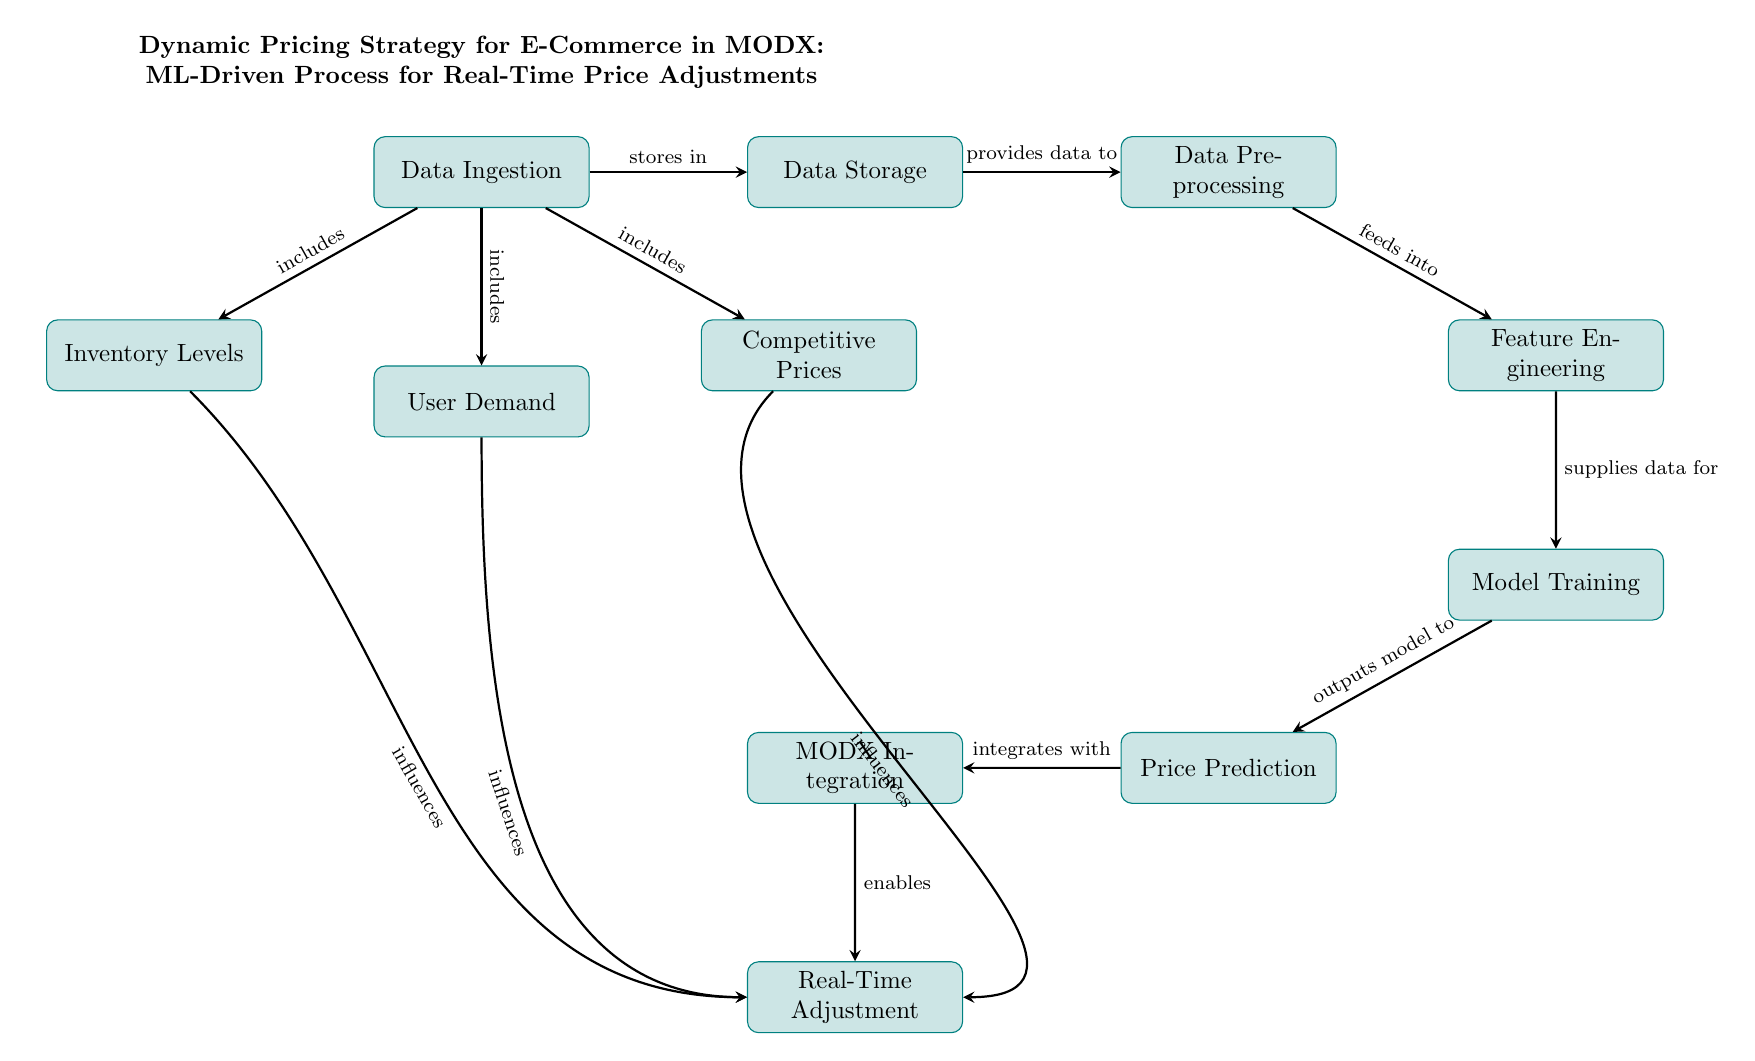What is the first step in the process? The first node in the diagram is "Data Ingestion," which represents the initial step of collecting various data types necessary for the dynamic pricing strategy.
Answer: Data Ingestion How many main processes are depicted in the diagram? The diagram includes a total of seven main processes, which are the nodes that represent steps in the machine learning-driven pricing strategy. These processes are connected by arrows indicating the flow of data.
Answer: Seven What influences the “Real-Time Adjustment”? The “Real-Time Adjustment” node is influenced by three specific nodes: "Inventory Levels," "User Demand," and "Competitive Prices." Each provides data that affects pricing decisions in real-time.
Answer: Inventory Levels, User Demand, Competitive Prices Which node integrates with "MODX"? The node that integrates with "MODX" is "Price Prediction," as indicated by the arrow connecting the two nodes, representing the data output that feeds into MODX for implementation.
Answer: Price Prediction What does the "Data Preprocessing" node provide data to? The "Data Preprocessing" node provides data to the "Feature Engineering" node, as shown by the directed arrow indicating that the output of preprocessing is necessary for feature engineering.
Answer: Feature Engineering How many edges are there in the diagram? By counting the arrows connecting the processes, there are a total of ten edges in the diagram, signifying the connections and flow of data between the steps.
Answer: Ten What is the outcome of the "Model Training" node? The "Model Training" node outputs a model to the "Price Prediction" node, as shown by the connecting arrow, indicating that the results of training will affect pricing predictions.
Answer: Outputs model to Price Prediction What type of data does the "Data Ingestion" step collect? The "Data Ingestion" step collects data types related to inventory levels, user demand, and competitive prices, as depicted by the connections to these nodes in the diagram.
Answer: Inventory Levels, User Demand, Competitive Prices 